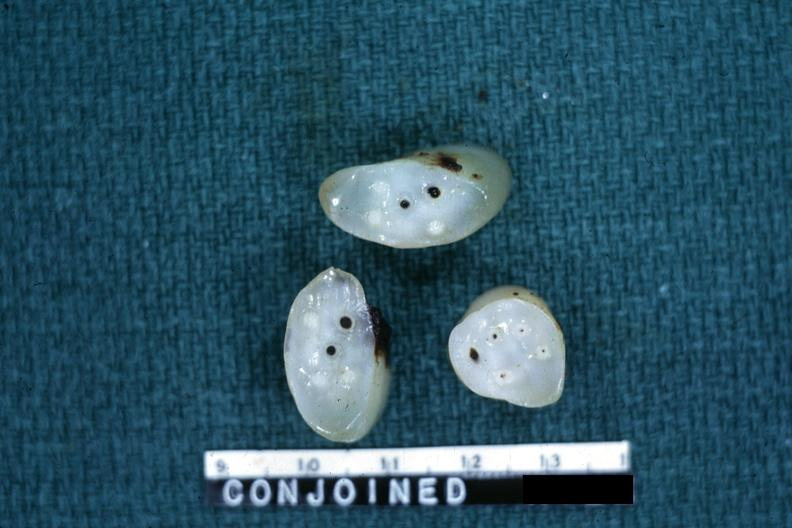how many arteries does this image show cross sections showing apparently and two veins?
Answer the question using a single word or phrase. Four 